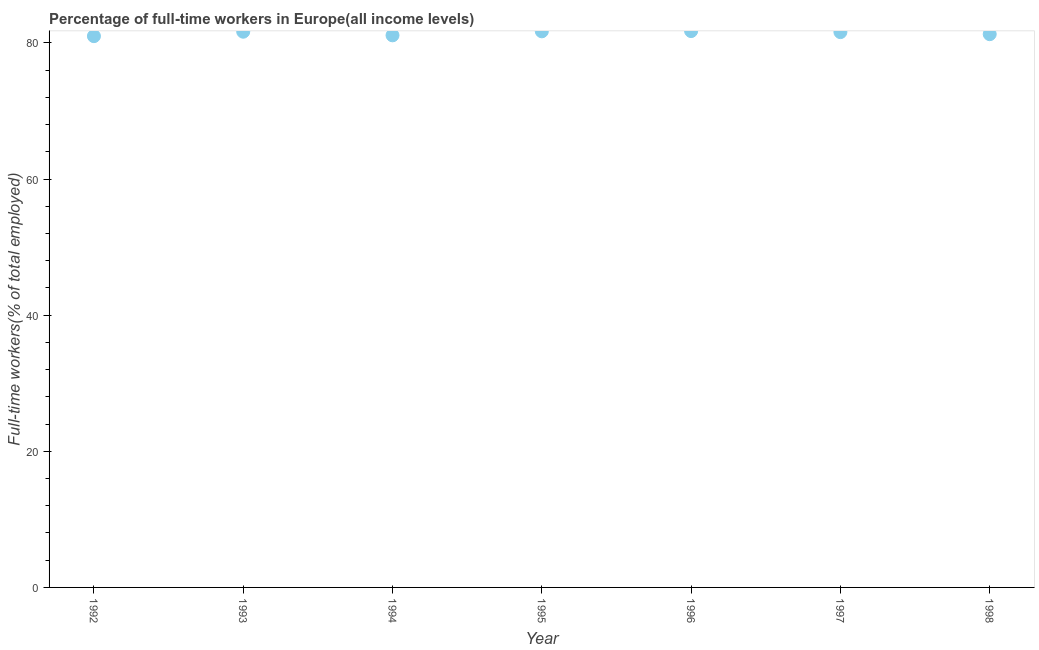What is the percentage of full-time workers in 1992?
Give a very brief answer. 80.99. Across all years, what is the maximum percentage of full-time workers?
Provide a short and direct response. 81.74. Across all years, what is the minimum percentage of full-time workers?
Offer a terse response. 80.99. In which year was the percentage of full-time workers maximum?
Keep it short and to the point. 1996. What is the sum of the percentage of full-time workers?
Keep it short and to the point. 570.07. What is the difference between the percentage of full-time workers in 1995 and 1997?
Offer a terse response. 0.11. What is the average percentage of full-time workers per year?
Offer a very short reply. 81.44. What is the median percentage of full-time workers?
Offer a very short reply. 81.59. In how many years, is the percentage of full-time workers greater than 56 %?
Offer a very short reply. 7. Do a majority of the years between 1996 and 1997 (inclusive) have percentage of full-time workers greater than 20 %?
Offer a terse response. Yes. What is the ratio of the percentage of full-time workers in 1993 to that in 1998?
Offer a terse response. 1. What is the difference between the highest and the second highest percentage of full-time workers?
Your answer should be very brief. 0.04. Is the sum of the percentage of full-time workers in 1994 and 1996 greater than the maximum percentage of full-time workers across all years?
Ensure brevity in your answer.  Yes. What is the difference between the highest and the lowest percentage of full-time workers?
Ensure brevity in your answer.  0.75. In how many years, is the percentage of full-time workers greater than the average percentage of full-time workers taken over all years?
Your response must be concise. 4. Does the percentage of full-time workers monotonically increase over the years?
Offer a very short reply. No. How many dotlines are there?
Offer a very short reply. 1. Does the graph contain any zero values?
Your answer should be compact. No. Does the graph contain grids?
Offer a terse response. No. What is the title of the graph?
Ensure brevity in your answer.  Percentage of full-time workers in Europe(all income levels). What is the label or title of the X-axis?
Give a very brief answer. Year. What is the label or title of the Y-axis?
Make the answer very short. Full-time workers(% of total employed). What is the Full-time workers(% of total employed) in 1992?
Offer a very short reply. 80.99. What is the Full-time workers(% of total employed) in 1993?
Make the answer very short. 81.65. What is the Full-time workers(% of total employed) in 1994?
Offer a terse response. 81.12. What is the Full-time workers(% of total employed) in 1995?
Ensure brevity in your answer.  81.7. What is the Full-time workers(% of total employed) in 1996?
Provide a short and direct response. 81.74. What is the Full-time workers(% of total employed) in 1997?
Keep it short and to the point. 81.59. What is the Full-time workers(% of total employed) in 1998?
Give a very brief answer. 81.29. What is the difference between the Full-time workers(% of total employed) in 1992 and 1993?
Provide a succinct answer. -0.65. What is the difference between the Full-time workers(% of total employed) in 1992 and 1994?
Your answer should be compact. -0.12. What is the difference between the Full-time workers(% of total employed) in 1992 and 1995?
Make the answer very short. -0.71. What is the difference between the Full-time workers(% of total employed) in 1992 and 1996?
Your response must be concise. -0.75. What is the difference between the Full-time workers(% of total employed) in 1992 and 1997?
Provide a short and direct response. -0.59. What is the difference between the Full-time workers(% of total employed) in 1992 and 1998?
Offer a terse response. -0.29. What is the difference between the Full-time workers(% of total employed) in 1993 and 1994?
Offer a very short reply. 0.53. What is the difference between the Full-time workers(% of total employed) in 1993 and 1995?
Keep it short and to the point. -0.06. What is the difference between the Full-time workers(% of total employed) in 1993 and 1996?
Provide a short and direct response. -0.09. What is the difference between the Full-time workers(% of total employed) in 1993 and 1997?
Your answer should be very brief. 0.06. What is the difference between the Full-time workers(% of total employed) in 1993 and 1998?
Offer a terse response. 0.36. What is the difference between the Full-time workers(% of total employed) in 1994 and 1995?
Offer a terse response. -0.59. What is the difference between the Full-time workers(% of total employed) in 1994 and 1996?
Provide a short and direct response. -0.62. What is the difference between the Full-time workers(% of total employed) in 1994 and 1997?
Your answer should be very brief. -0.47. What is the difference between the Full-time workers(% of total employed) in 1994 and 1998?
Provide a succinct answer. -0.17. What is the difference between the Full-time workers(% of total employed) in 1995 and 1996?
Keep it short and to the point. -0.04. What is the difference between the Full-time workers(% of total employed) in 1995 and 1997?
Give a very brief answer. 0.11. What is the difference between the Full-time workers(% of total employed) in 1995 and 1998?
Offer a very short reply. 0.42. What is the difference between the Full-time workers(% of total employed) in 1996 and 1997?
Provide a succinct answer. 0.15. What is the difference between the Full-time workers(% of total employed) in 1996 and 1998?
Your answer should be very brief. 0.45. What is the difference between the Full-time workers(% of total employed) in 1997 and 1998?
Your response must be concise. 0.3. What is the ratio of the Full-time workers(% of total employed) in 1992 to that in 1995?
Keep it short and to the point. 0.99. What is the ratio of the Full-time workers(% of total employed) in 1992 to that in 1997?
Offer a very short reply. 0.99. What is the ratio of the Full-time workers(% of total employed) in 1992 to that in 1998?
Give a very brief answer. 1. What is the ratio of the Full-time workers(% of total employed) in 1993 to that in 1994?
Your response must be concise. 1.01. What is the ratio of the Full-time workers(% of total employed) in 1993 to that in 1995?
Provide a succinct answer. 1. What is the ratio of the Full-time workers(% of total employed) in 1993 to that in 1996?
Provide a succinct answer. 1. What is the ratio of the Full-time workers(% of total employed) in 1994 to that in 1996?
Provide a succinct answer. 0.99. What is the ratio of the Full-time workers(% of total employed) in 1995 to that in 1997?
Give a very brief answer. 1. What is the ratio of the Full-time workers(% of total employed) in 1996 to that in 1997?
Ensure brevity in your answer.  1. What is the ratio of the Full-time workers(% of total employed) in 1996 to that in 1998?
Provide a short and direct response. 1.01. 